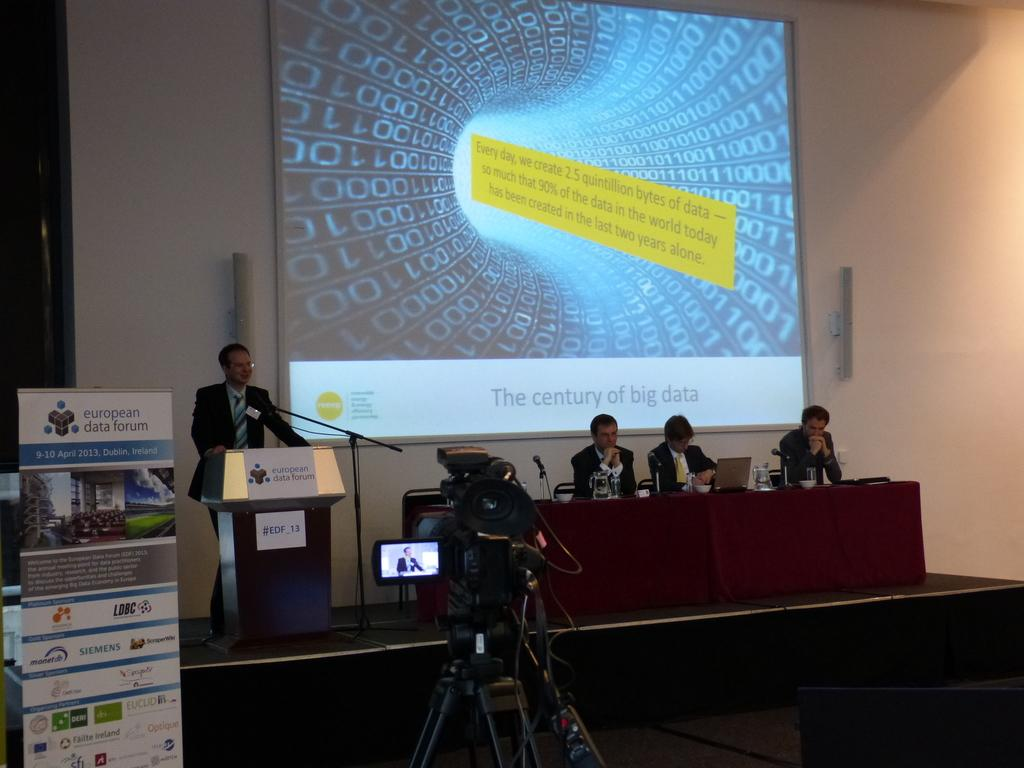<image>
Share a concise interpretation of the image provided. man giving lecture on stage at european data forum in dublin, ireland 